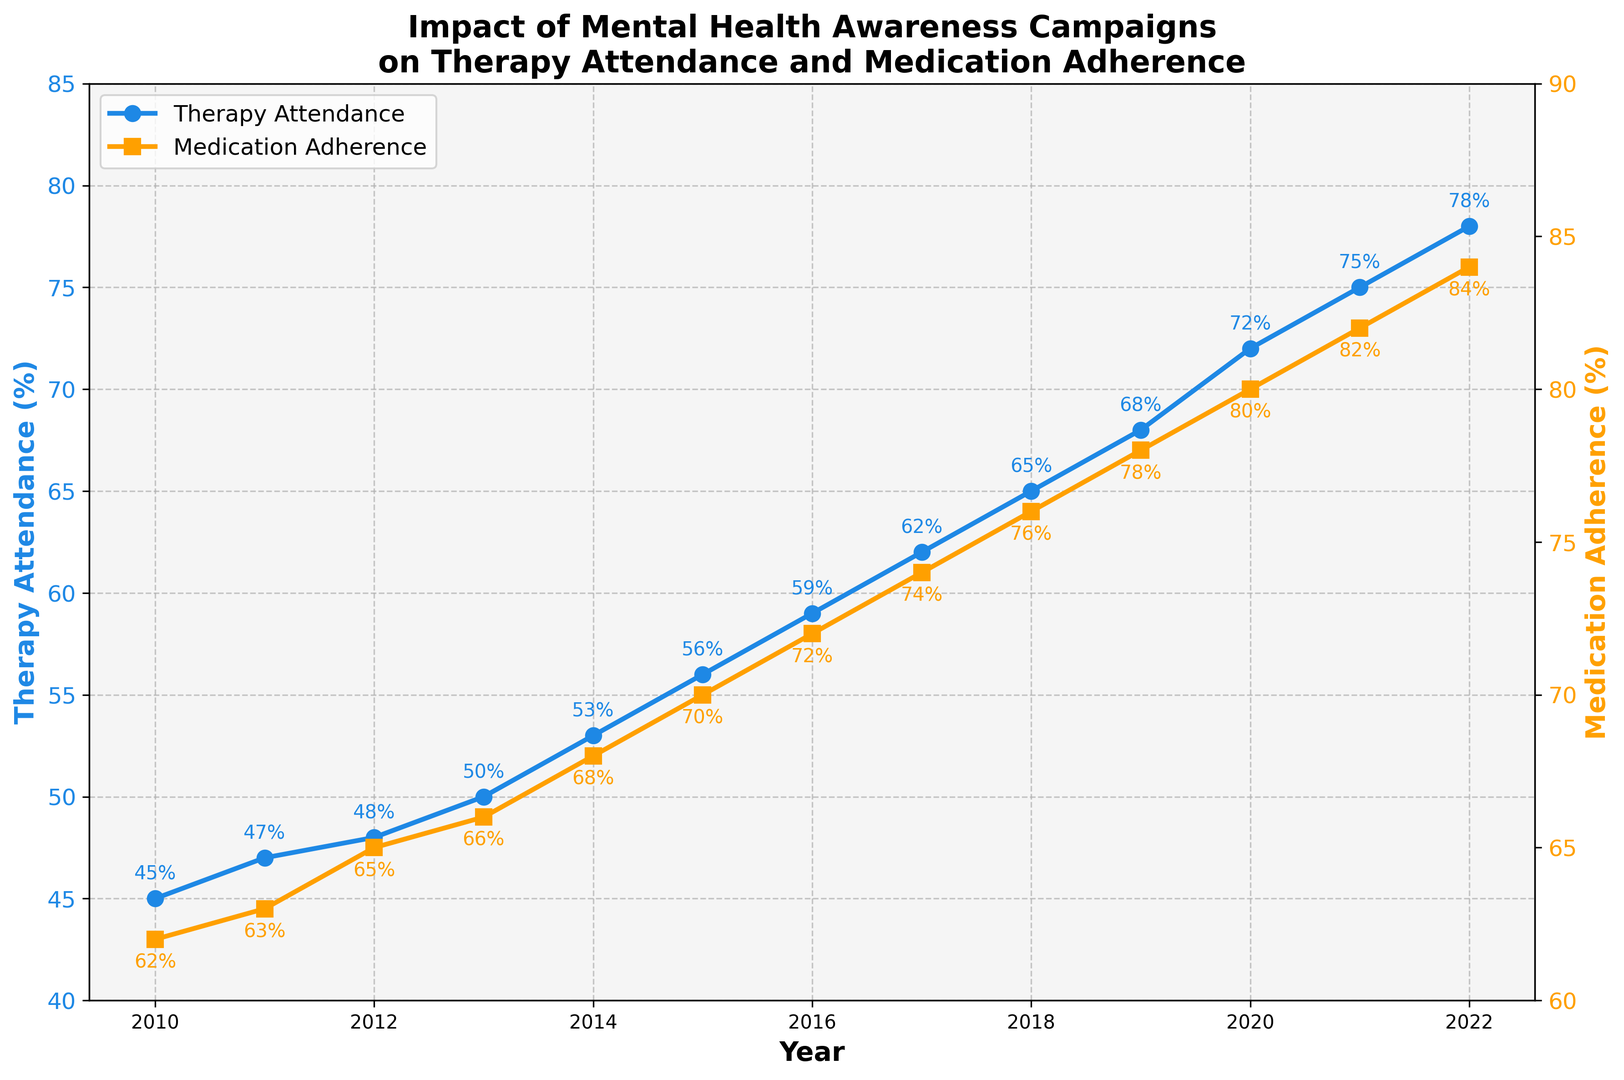What trend is observed in Therapy Attendance from 2010 to 2022? Explanation: By looking at the plotted line representing Therapy Attendance, we observe that the values increase consistently from 45% in 2010 to 78% in 2022.
Answer: Increasing trend What is the difference in Medication Adherence between 2010 and 2022? Explanation: Medication Adherence is 62% in 2010 and 84% in 2022. The difference is 84% - 62% = 22%.
Answer: 22% Compare the Therapy Attendance in 2016 to that in 2019. Which year had a higher percentage and by how much? Explanation: Therapy Attendance in 2016 is 59%, and in 2019, it is 68%. The difference is 68% - 59% = 9%. Thus, 2019 had a higher percentage by 9%.
Answer: 2019 by 9% What year sees Therapy Attendance reach 50%? Explanation: By reading the Therapy Attendance line, we see that in 2013 the attendance is 50%.
Answer: 2013 In which year did both Therapy Attendance and Medication Adherence increase the most compared to the previous year? Explanation: To find the year with the biggest increase, calculate the year-to-year differences for both therapy and medication adherence from 2010 to 2022 and sum them. The largest summed increase occurs between 2019 and 2020.
Answer: Between 2019 and 2020 What is the average Therapy Attendance over the entire period presented in the figure? Explanation: Sum up all the Therapy Attendance percentages from 2010 to 2022 and divide by the number of years (13). (45 + 47 + 48 + 50 + 53 + 56 + 59 + 62 + 65 + 68 + 72 + 75 + 78) / 13 = 60.8%.
Answer: 60.8% Look at the color-coded lines representing Therapy Attendance and Medication Adherence. Which color represents each, and how can you tell? Explanation: The Therapy Attendance line is blue with circle markers, and the Medication Adherence line is orange with square markers, as indicated by the legend and color on the labels on each axis.
Answer: Blue for Therapy Attendance, Orange for Medication Adherence What year did Medication Adherence first surpass 70%? Explanation: Observing the Medication Adherence line, we see that it first hits above 70% in 2015 with exactly 70% adherence.
Answer: 2015 